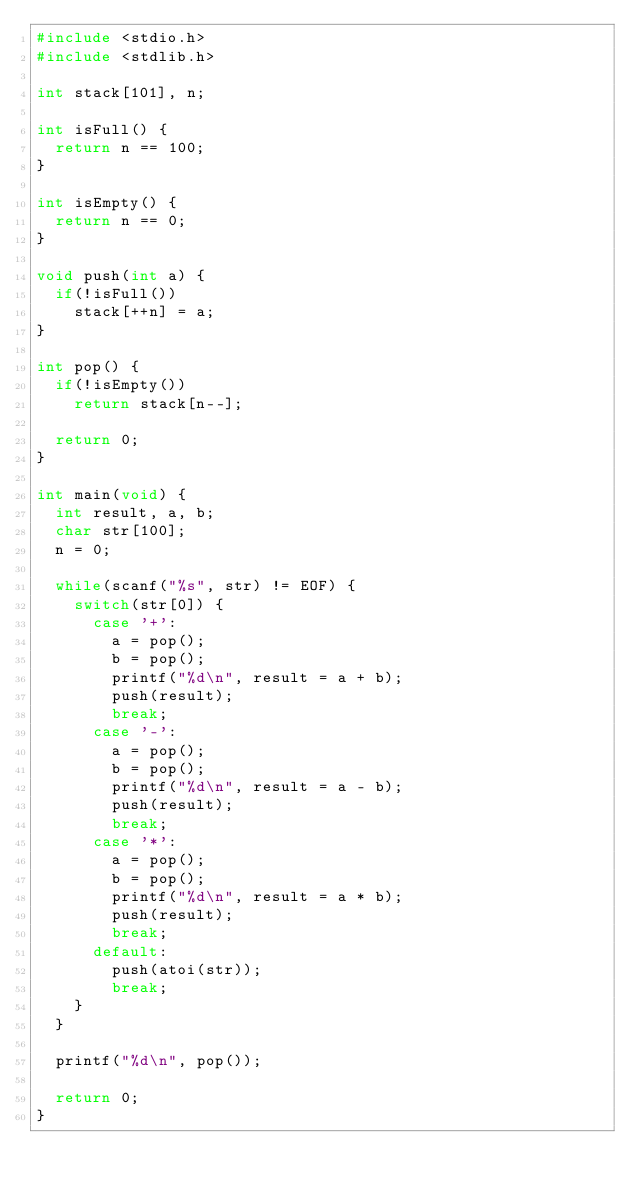Convert code to text. <code><loc_0><loc_0><loc_500><loc_500><_C_>#include <stdio.h>
#include <stdlib.h>

int stack[101], n;

int isFull() {
  return n == 100;
}

int isEmpty() {
  return n == 0;
}

void push(int a) {
  if(!isFull())
    stack[++n] = a;
}

int pop() {
  if(!isEmpty())
    return stack[n--];

  return 0;
}

int main(void) {
  int result, a, b;
  char str[100];
  n = 0;

  while(scanf("%s", str) != EOF) {
    switch(str[0]) {
      case '+':
        a = pop();
        b = pop();
        printf("%d\n", result = a + b);
        push(result);
        break;
      case '-':
        a = pop();
        b = pop();
        printf("%d\n", result = a - b);
        push(result);
        break;
      case '*':
        a = pop();
        b = pop();
        printf("%d\n", result = a * b);
        push(result);
        break;
      default:
        push(atoi(str));
        break;
    }
  }

  printf("%d\n", pop());

  return 0;
}

</code> 